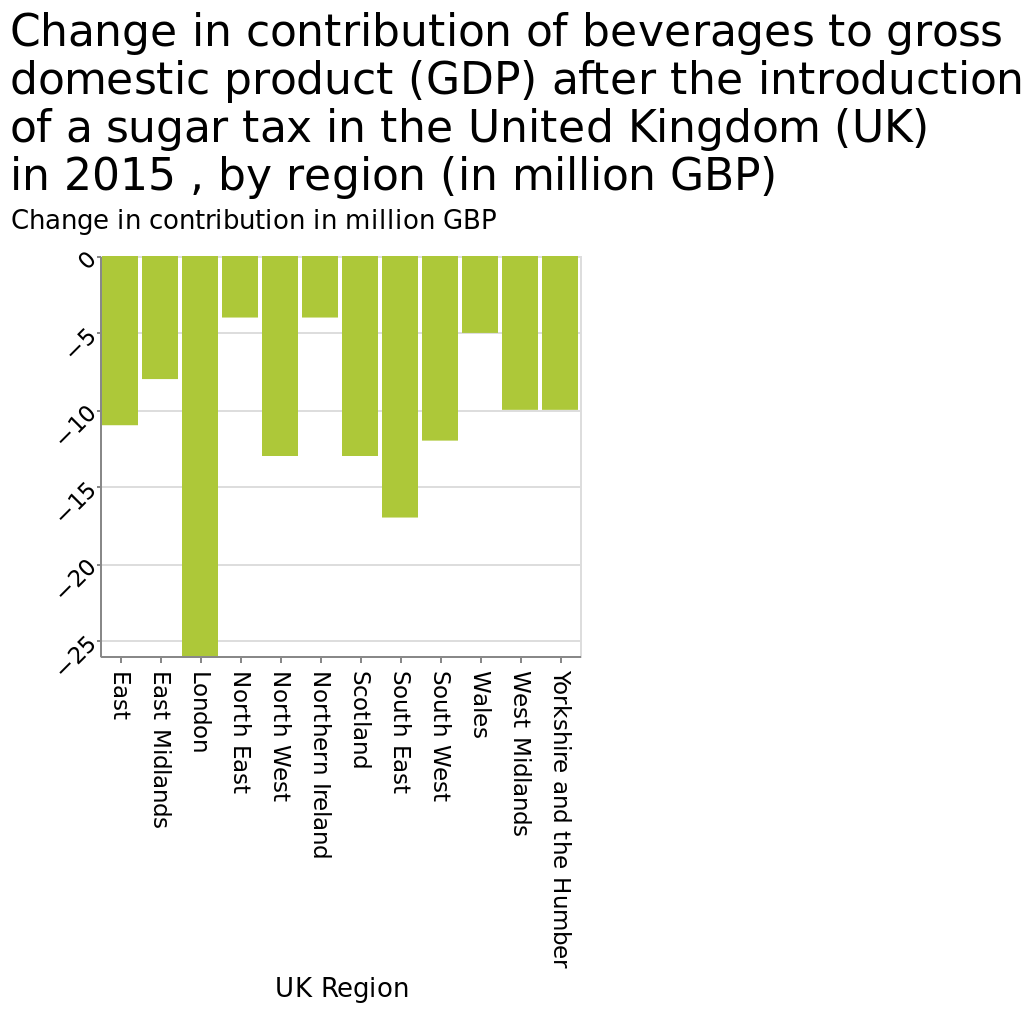<image>
Where has the biggest change been according to the figure? According to the figure, the biggest change has been in London. please summary the statistics and relations of the chart The smallest change has been in the north east and Scotland. The biggest change has been in London. What region has seen the smallest change according to the figure? The north east and Scotland have seen the smallest change. 